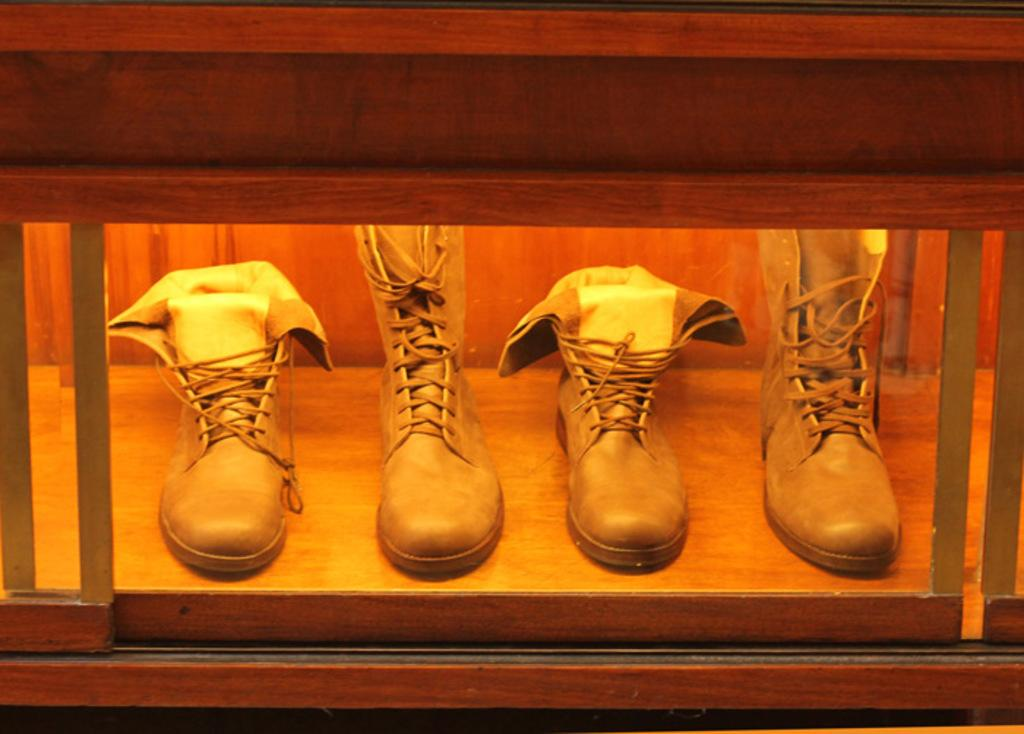What color are the shoes in the image? The shoes in the image are brown. Where are the shoes located in the image? The shoes are inside a wooden box. How many attempts does the self-made basket have in the image? There is no self-made basket present in the image. 